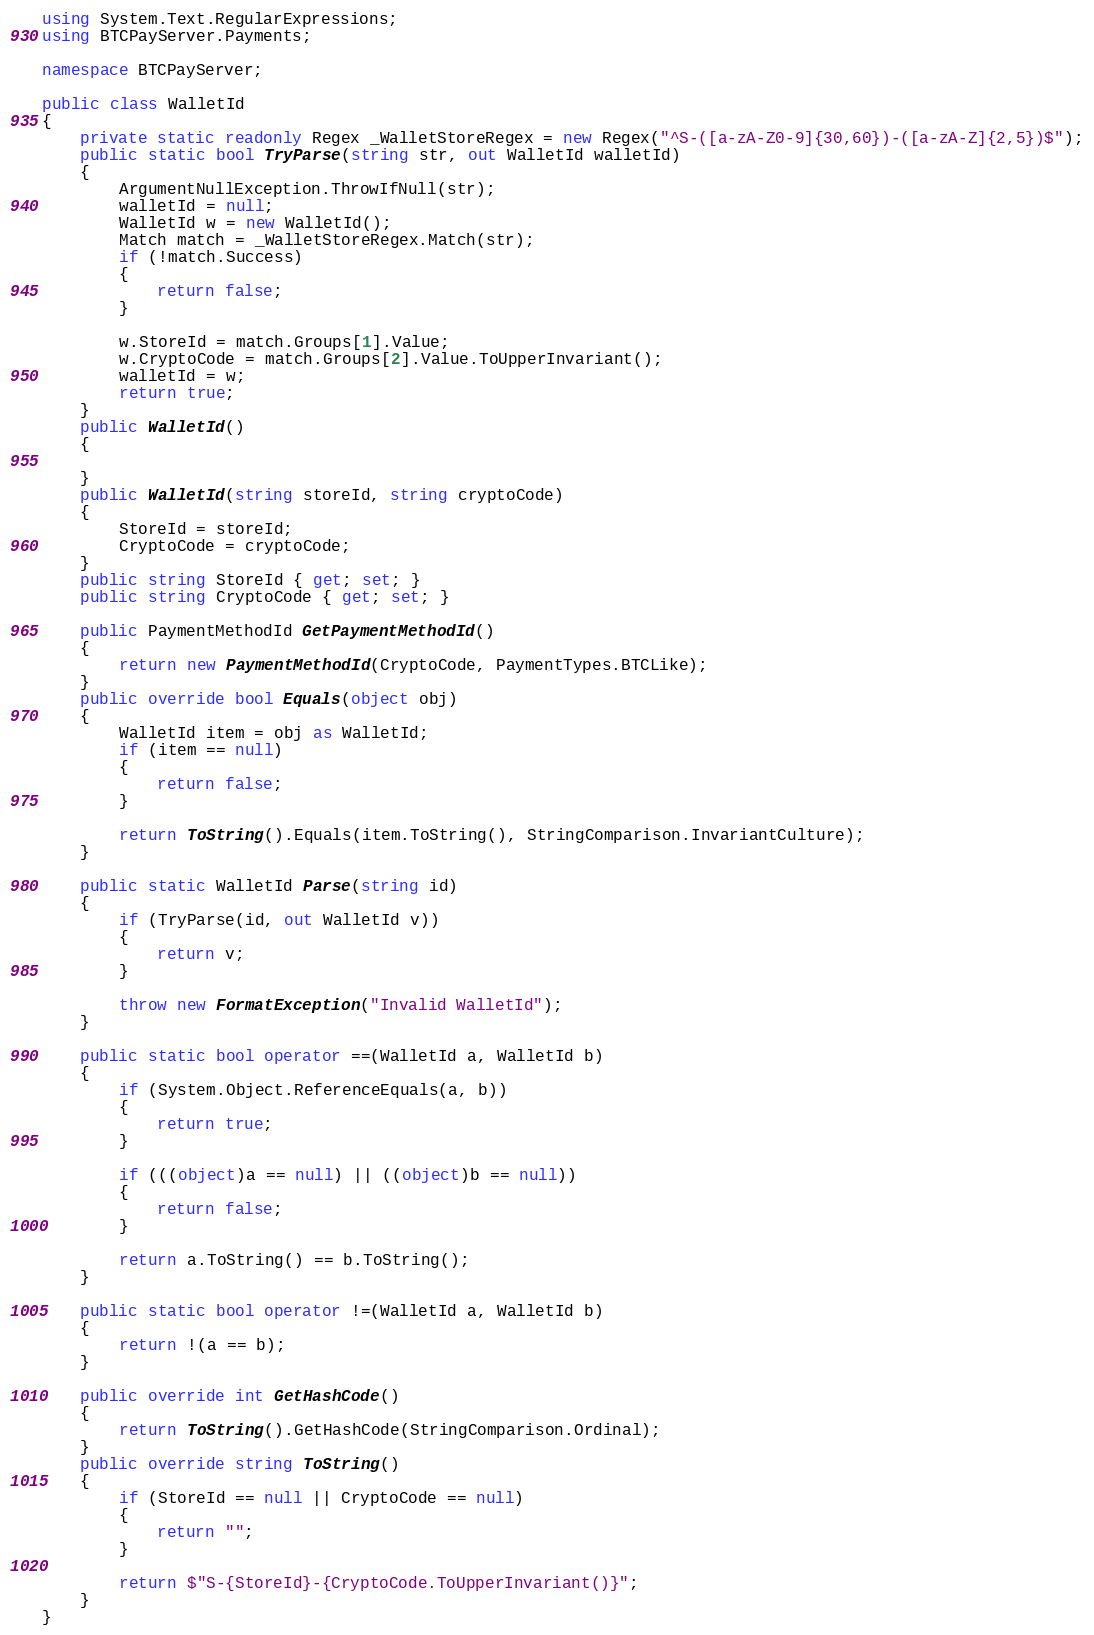<code> <loc_0><loc_0><loc_500><loc_500><_C#_>using System.Text.RegularExpressions;
using BTCPayServer.Payments;

namespace BTCPayServer;

public class WalletId
{
    private static readonly Regex _WalletStoreRegex = new Regex("^S-([a-zA-Z0-9]{30,60})-([a-zA-Z]{2,5})$");
    public static bool TryParse(string str, out WalletId walletId)
    {
        ArgumentNullException.ThrowIfNull(str);
        walletId = null;
        WalletId w = new WalletId();
        Match match = _WalletStoreRegex.Match(str);
        if (!match.Success)
        {
            return false;
        }

        w.StoreId = match.Groups[1].Value;
        w.CryptoCode = match.Groups[2].Value.ToUpperInvariant();
        walletId = w;
        return true;
    }
    public WalletId()
    {

    }
    public WalletId(string storeId, string cryptoCode)
    {
        StoreId = storeId;
        CryptoCode = cryptoCode;
    }
    public string StoreId { get; set; }
    public string CryptoCode { get; set; }

    public PaymentMethodId GetPaymentMethodId()
    {
        return new PaymentMethodId(CryptoCode, PaymentTypes.BTCLike);
    }
    public override bool Equals(object obj)
    {
        WalletId item = obj as WalletId;
        if (item == null)
        {
            return false;
        }

        return ToString().Equals(item.ToString(), StringComparison.InvariantCulture);
    }

    public static WalletId Parse(string id)
    {
        if (TryParse(id, out WalletId v))
        {
            return v;
        }

        throw new FormatException("Invalid WalletId");
    }

    public static bool operator ==(WalletId a, WalletId b)
    {
        if (System.Object.ReferenceEquals(a, b))
        {
            return true;
        }

        if (((object)a == null) || ((object)b == null))
        {
            return false;
        }

        return a.ToString() == b.ToString();
    }

    public static bool operator !=(WalletId a, WalletId b)
    {
        return !(a == b);
    }

    public override int GetHashCode()
    {
        return ToString().GetHashCode(StringComparison.Ordinal);
    }
    public override string ToString()
    {
        if (StoreId == null || CryptoCode == null)
        {
            return "";
        }

        return $"S-{StoreId}-{CryptoCode.ToUpperInvariant()}";
    }
}
</code> 